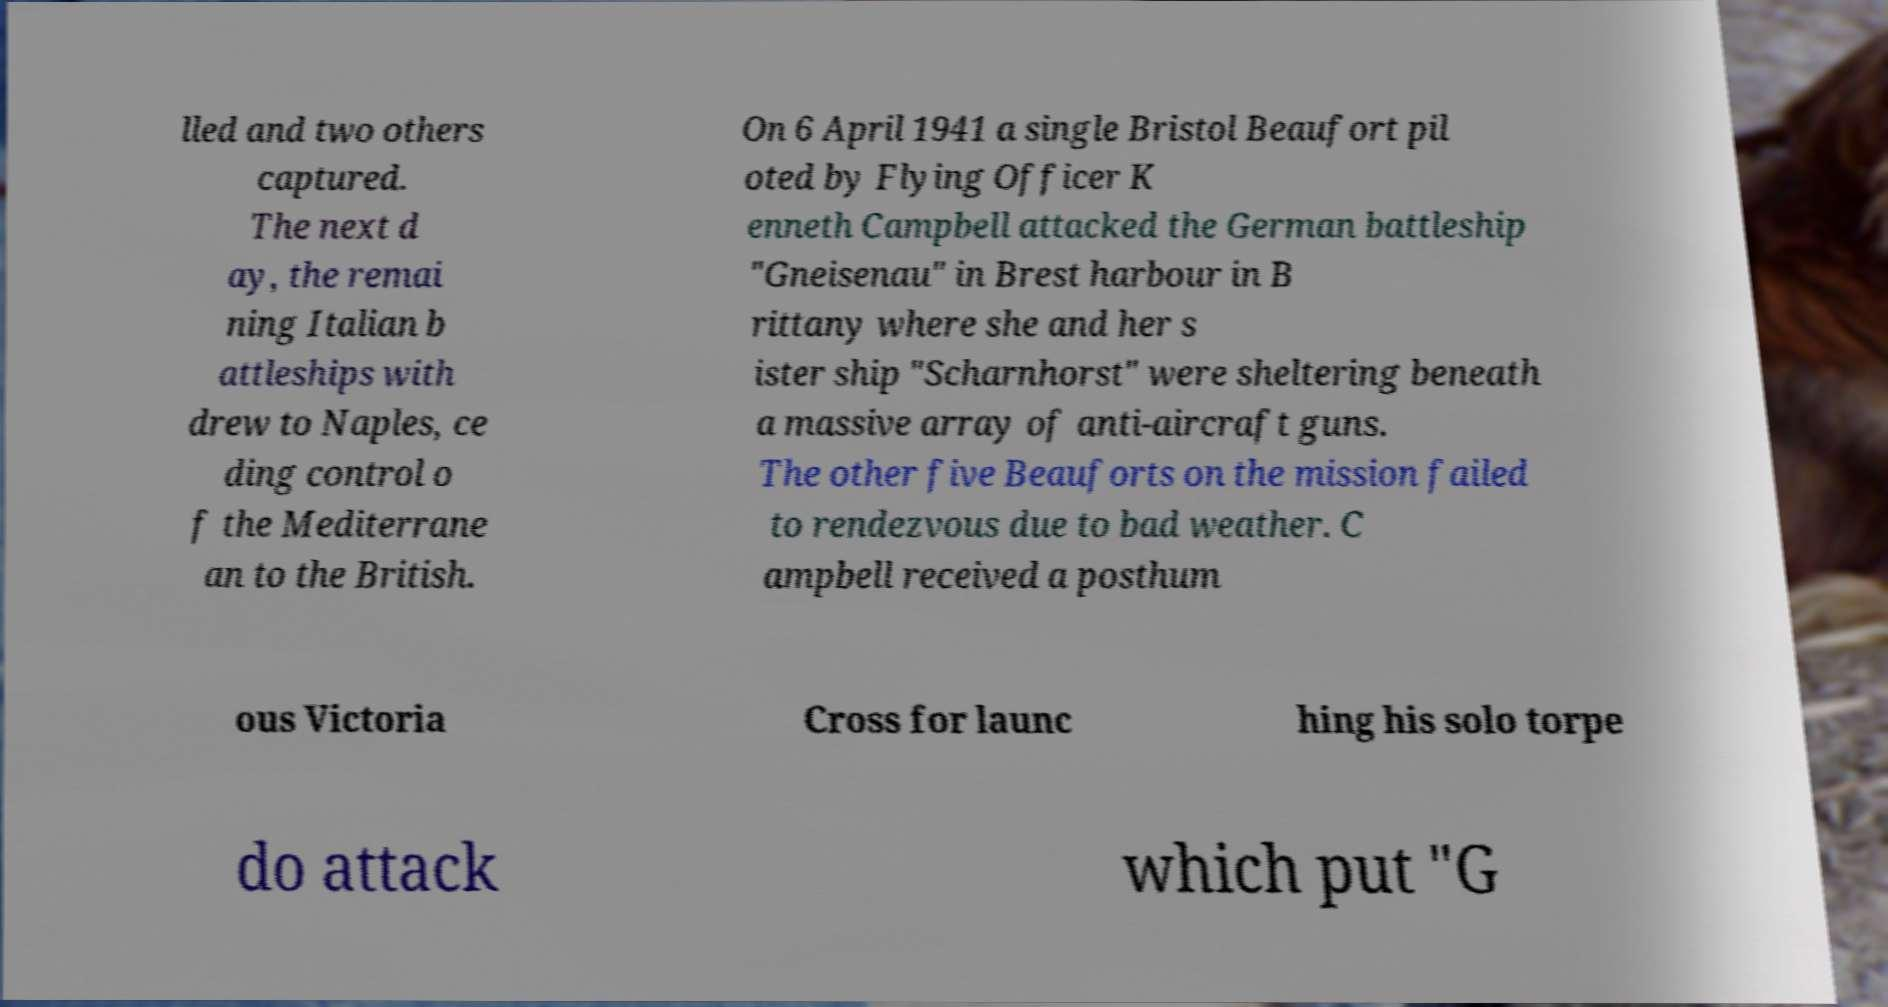Please read and relay the text visible in this image. What does it say? lled and two others captured. The next d ay, the remai ning Italian b attleships with drew to Naples, ce ding control o f the Mediterrane an to the British. On 6 April 1941 a single Bristol Beaufort pil oted by Flying Officer K enneth Campbell attacked the German battleship "Gneisenau" in Brest harbour in B rittany where she and her s ister ship "Scharnhorst" were sheltering beneath a massive array of anti-aircraft guns. The other five Beauforts on the mission failed to rendezvous due to bad weather. C ampbell received a posthum ous Victoria Cross for launc hing his solo torpe do attack which put "G 